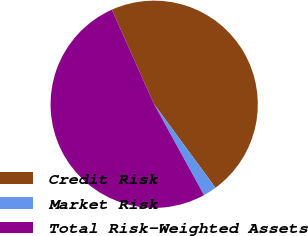Convert chart. <chart><loc_0><loc_0><loc_500><loc_500><pie_chart><fcel>Credit Risk<fcel>Market Risk<fcel>Total Risk-Weighted Assets<nl><fcel>46.63%<fcel>2.09%<fcel>51.29%<nl></chart> 